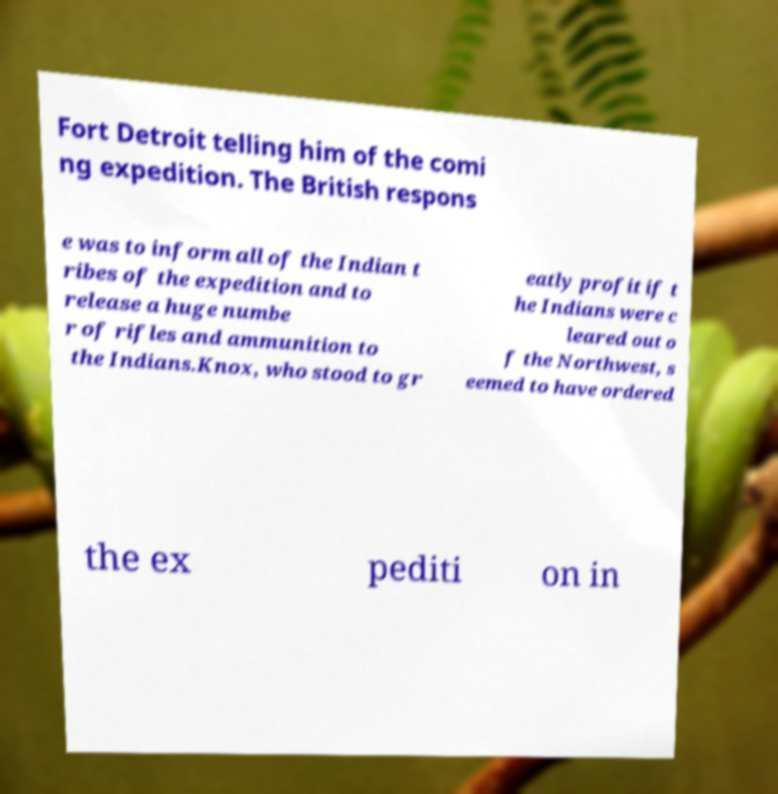Please read and relay the text visible in this image. What does it say? Fort Detroit telling him of the comi ng expedition. The British respons e was to inform all of the Indian t ribes of the expedition and to release a huge numbe r of rifles and ammunition to the Indians.Knox, who stood to gr eatly profit if t he Indians were c leared out o f the Northwest, s eemed to have ordered the ex pediti on in 